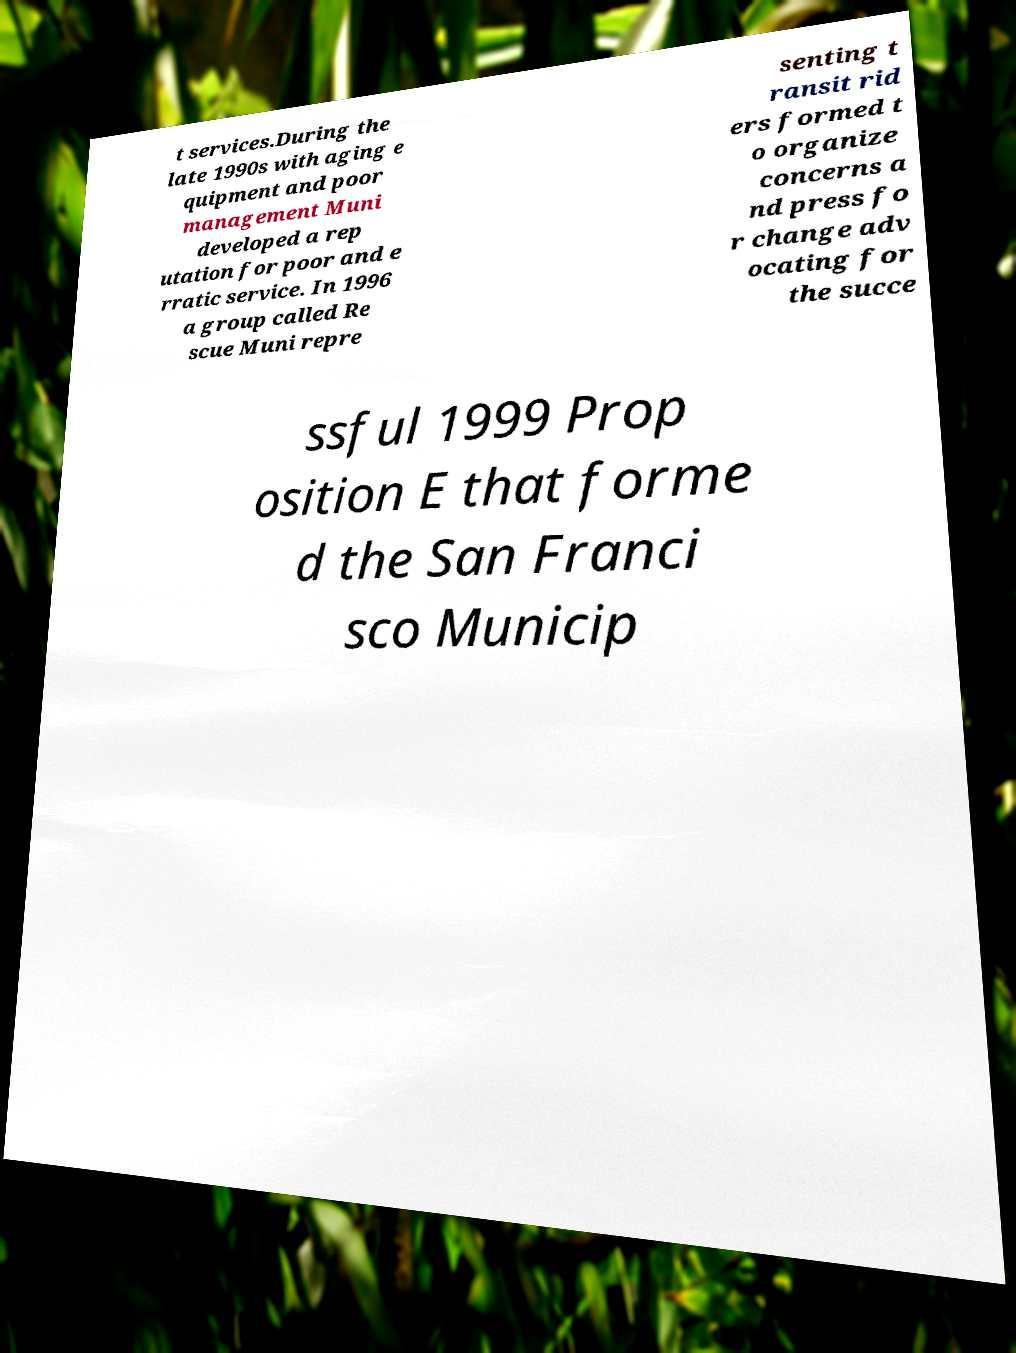Could you extract and type out the text from this image? t services.During the late 1990s with aging e quipment and poor management Muni developed a rep utation for poor and e rratic service. In 1996 a group called Re scue Muni repre senting t ransit rid ers formed t o organize concerns a nd press fo r change adv ocating for the succe ssful 1999 Prop osition E that forme d the San Franci sco Municip 